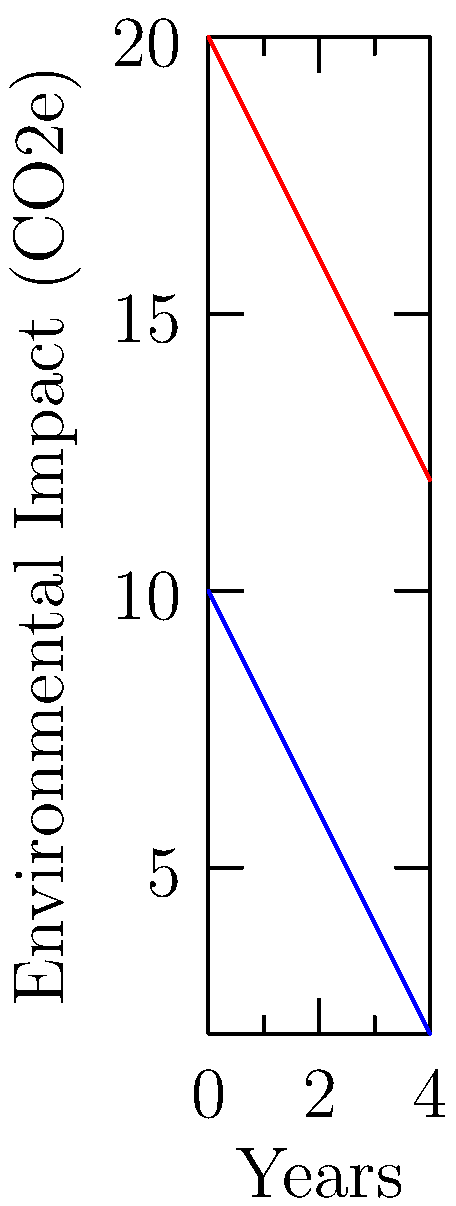Based on the comparative flowchart showing the environmental impact of vegan and non-vegan menu items over time, estimate the difference in CO2e emissions between vegan and non-vegan options after 4 years. To estimate the difference in CO2e emissions between vegan and non-vegan options after 4 years:

1. Locate the 4-year mark on the x-axis.
2. Find the corresponding y-values for both vegan and non-vegan lines at the 4-year mark.
3. Vegan impact at 4 years: approximately 2 CO2e
4. Non-vegan impact at 4 years: approximately 12 CO2e
5. Calculate the difference: 12 CO2e - 2 CO2e = 10 CO2e

The difference in environmental impact between vegan and non-vegan options after 4 years is estimated to be 10 CO2e.
Answer: 10 CO2e 